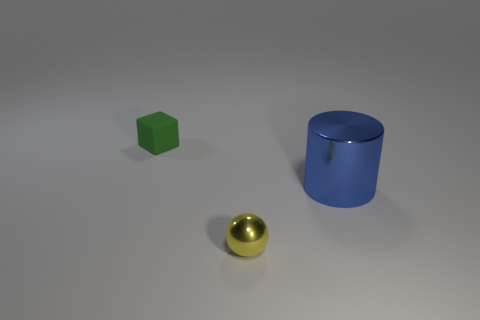Add 2 large gray rubber things. How many objects exist? 5 Subtract all cylinders. How many objects are left? 2 Subtract 1 balls. How many balls are left? 0 Subtract 1 blue cylinders. How many objects are left? 2 Subtract all green balls. Subtract all purple cylinders. How many balls are left? 1 Subtract all tiny yellow things. Subtract all tiny green things. How many objects are left? 1 Add 3 blue metallic objects. How many blue metallic objects are left? 4 Add 1 tiny cyan rubber objects. How many tiny cyan rubber objects exist? 1 